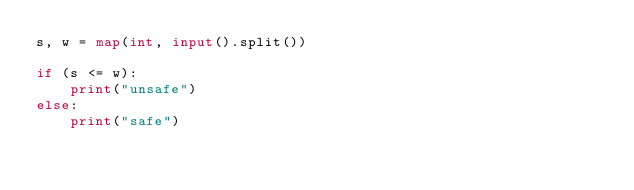Convert code to text. <code><loc_0><loc_0><loc_500><loc_500><_Python_>s, w = map(int, input().split())

if (s <= w):
    print("unsafe")
else:
    print("safe")</code> 